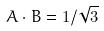Convert formula to latex. <formula><loc_0><loc_0><loc_500><loc_500>A \cdot B = 1 / \sqrt { 3 }</formula> 